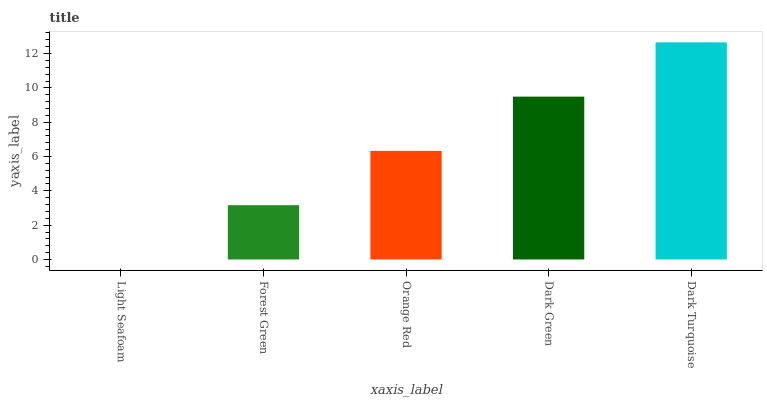Is Light Seafoam the minimum?
Answer yes or no. Yes. Is Dark Turquoise the maximum?
Answer yes or no. Yes. Is Forest Green the minimum?
Answer yes or no. No. Is Forest Green the maximum?
Answer yes or no. No. Is Forest Green greater than Light Seafoam?
Answer yes or no. Yes. Is Light Seafoam less than Forest Green?
Answer yes or no. Yes. Is Light Seafoam greater than Forest Green?
Answer yes or no. No. Is Forest Green less than Light Seafoam?
Answer yes or no. No. Is Orange Red the high median?
Answer yes or no. Yes. Is Orange Red the low median?
Answer yes or no. Yes. Is Forest Green the high median?
Answer yes or no. No. Is Dark Turquoise the low median?
Answer yes or no. No. 